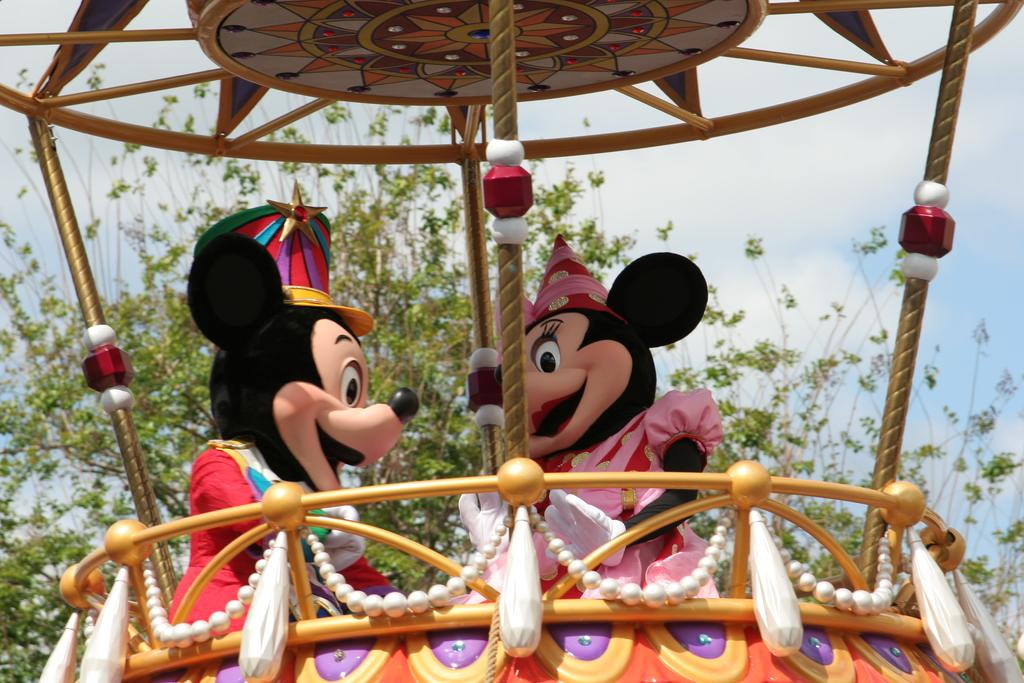What is the main subject of the image? The image appears to depict an amusement ride. Can you describe the people in the image? There are two persons wearing costumes in the image. What can be seen in the background of the image? There are many trees in the background of the image. What is visible at the top of the image? The sky is visible at the top of the image. What type of creature is driving the amusement ride in the image? There is no creature driving the amusement ride in the image; it is an amusement ride, not a vehicle. How many light bulbs are present on the amusement ride in the image? There is no mention of light bulbs in the image; it only depicts an amusement ride and people wearing costumes. 